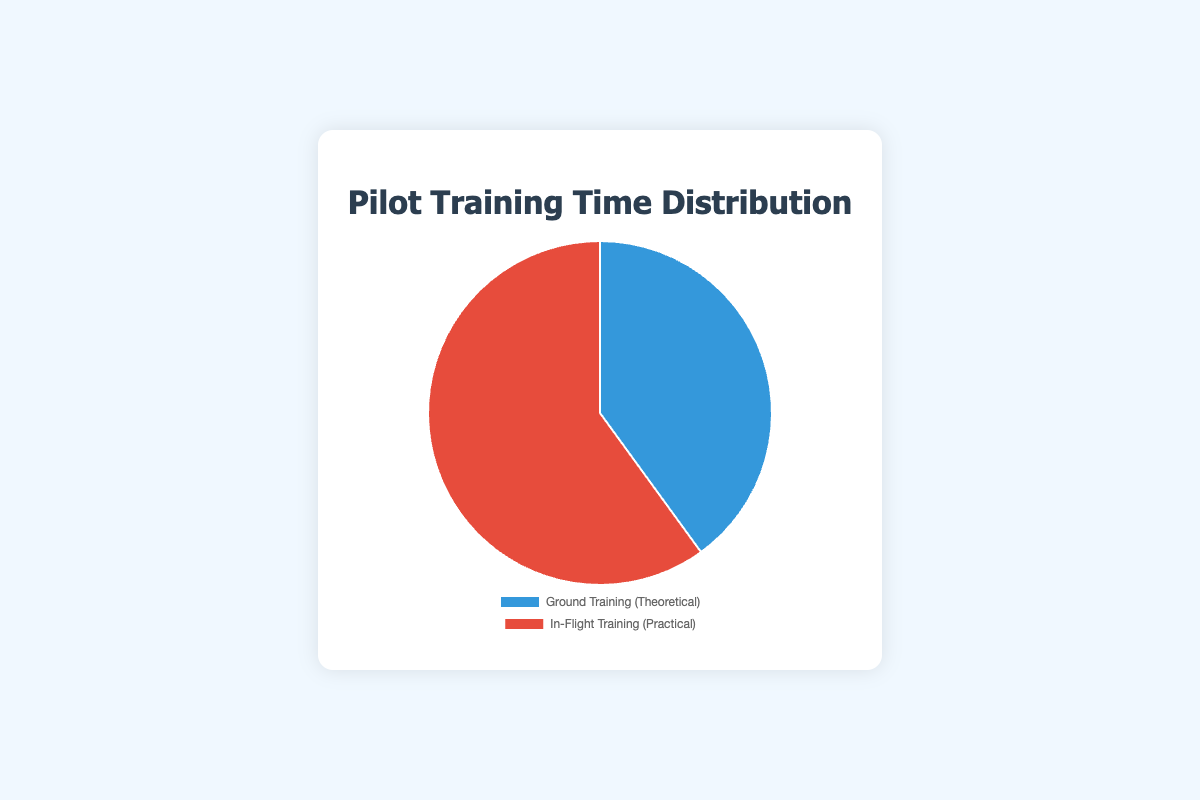How much more time is spent on practical training compared to theoretical training? The figure shows that 180 hours are spent on practical training and 120 hours on theoretical training. The difference is 180 - 120 = 60 hours.
Answer: 60 hours What's the total time spent on pilot training? The total time is the sum of the time spent on both theoretical and practical training. From the figure, this is 120 + 180 = 300 hours.
Answer: 300 hours What percentage of the total training time is spent on in-flight training? The in-flight training accounts for 180 hours out of a total of 300 hours. To find the percentage: (180/300) * 100 = 60%.
Answer: 60% Which training session has more hours, and by how much? Comparing the two sessions, in-flight training has more hours (180 hours) compared to ground training (120 hours). The difference is 180 - 120 = 60 hours.
Answer: In-flight training, 60 hours What color represents the theoretical training segment in the pie chart? The theoretical training segment in the pie chart is represented by the blue color.
Answer: Blue If each slice of the pie represents a proportion of the total training time, what is the approximate angle of the slice for ground training? Theoretical training accounts for 120 out of 300 hours. The proportion is 120/300, which is 0.4. The full circle is 360 degrees, so the angle is 0.4 * 360 = 144 degrees.
Answer: 144 degrees How does the time spent in theoretical training compare to the time spent in practical training? The theoretical training accounts for 40% (120 out of 300 hours), while the practical training accounts for 60% (180 out of 300 hours). Practical training is more extensive by 20%.
Answer: Practical training is more by 20% What is the ratio of theoretical training hours to practical training hours? The ratio of theoretical training to practical training is 120 hours to 180 hours. Simplified, this is 2:3.
Answer: 2:3 Which segment of the pie covers more area? Comparing the segments, the in-flight training (red) covers more area than theoretical training (blue).
Answer: In-flight training (red) If another training module of 100 hours was added to the total training, what would be the new percentage of time spent on ground training? The new total time would be 120 + 180 + 100 = 400 hours. The percentage for ground training would be (120/400) * 100 = 30%.
Answer: 30% 